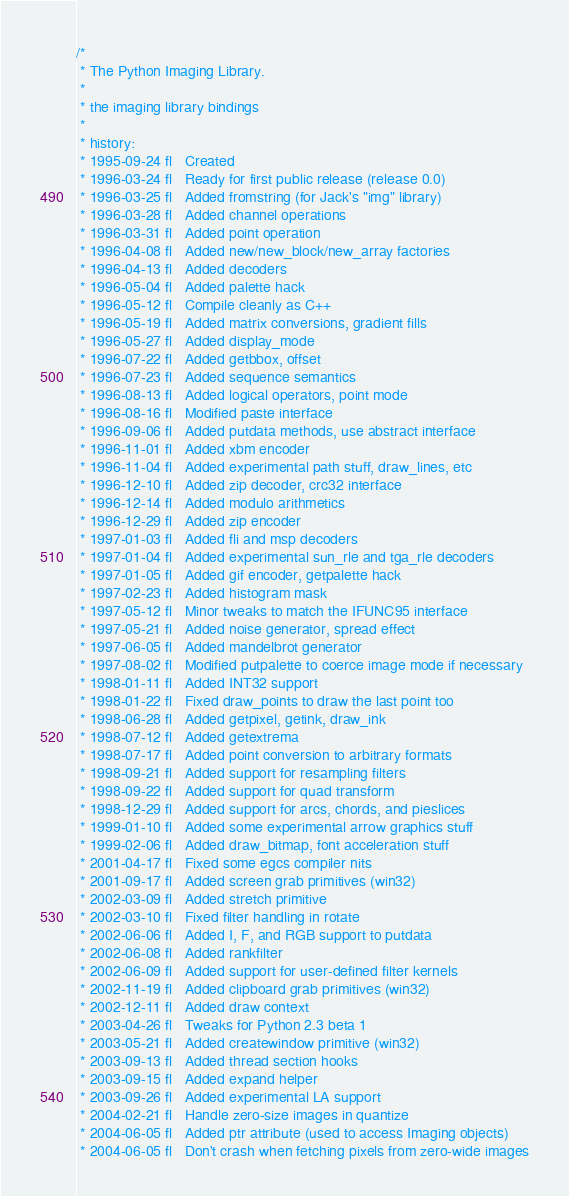<code> <loc_0><loc_0><loc_500><loc_500><_C_>/*
 * The Python Imaging Library.
 *
 * the imaging library bindings
 *
 * history:
 * 1995-09-24 fl   Created
 * 1996-03-24 fl   Ready for first public release (release 0.0)
 * 1996-03-25 fl   Added fromstring (for Jack's "img" library)
 * 1996-03-28 fl   Added channel operations
 * 1996-03-31 fl   Added point operation
 * 1996-04-08 fl   Added new/new_block/new_array factories
 * 1996-04-13 fl   Added decoders
 * 1996-05-04 fl   Added palette hack
 * 1996-05-12 fl   Compile cleanly as C++
 * 1996-05-19 fl   Added matrix conversions, gradient fills
 * 1996-05-27 fl   Added display_mode
 * 1996-07-22 fl   Added getbbox, offset
 * 1996-07-23 fl   Added sequence semantics
 * 1996-08-13 fl   Added logical operators, point mode
 * 1996-08-16 fl   Modified paste interface
 * 1996-09-06 fl   Added putdata methods, use abstract interface
 * 1996-11-01 fl   Added xbm encoder
 * 1996-11-04 fl   Added experimental path stuff, draw_lines, etc
 * 1996-12-10 fl   Added zip decoder, crc32 interface
 * 1996-12-14 fl   Added modulo arithmetics
 * 1996-12-29 fl   Added zip encoder
 * 1997-01-03 fl   Added fli and msp decoders
 * 1997-01-04 fl   Added experimental sun_rle and tga_rle decoders
 * 1997-01-05 fl   Added gif encoder, getpalette hack
 * 1997-02-23 fl   Added histogram mask
 * 1997-05-12 fl   Minor tweaks to match the IFUNC95 interface
 * 1997-05-21 fl   Added noise generator, spread effect
 * 1997-06-05 fl   Added mandelbrot generator
 * 1997-08-02 fl   Modified putpalette to coerce image mode if necessary
 * 1998-01-11 fl   Added INT32 support
 * 1998-01-22 fl   Fixed draw_points to draw the last point too
 * 1998-06-28 fl   Added getpixel, getink, draw_ink
 * 1998-07-12 fl   Added getextrema
 * 1998-07-17 fl   Added point conversion to arbitrary formats
 * 1998-09-21 fl   Added support for resampling filters
 * 1998-09-22 fl   Added support for quad transform
 * 1998-12-29 fl   Added support for arcs, chords, and pieslices
 * 1999-01-10 fl   Added some experimental arrow graphics stuff
 * 1999-02-06 fl   Added draw_bitmap, font acceleration stuff
 * 2001-04-17 fl   Fixed some egcs compiler nits
 * 2001-09-17 fl   Added screen grab primitives (win32)
 * 2002-03-09 fl   Added stretch primitive
 * 2002-03-10 fl   Fixed filter handling in rotate
 * 2002-06-06 fl   Added I, F, and RGB support to putdata
 * 2002-06-08 fl   Added rankfilter
 * 2002-06-09 fl   Added support for user-defined filter kernels
 * 2002-11-19 fl   Added clipboard grab primitives (win32)
 * 2002-12-11 fl   Added draw context
 * 2003-04-26 fl   Tweaks for Python 2.3 beta 1
 * 2003-05-21 fl   Added createwindow primitive (win32)
 * 2003-09-13 fl   Added thread section hooks
 * 2003-09-15 fl   Added expand helper
 * 2003-09-26 fl   Added experimental LA support
 * 2004-02-21 fl   Handle zero-size images in quantize
 * 2004-06-05 fl   Added ptr attribute (used to access Imaging objects)
 * 2004-06-05 fl   Don't crash when fetching pixels from zero-wide images</code> 